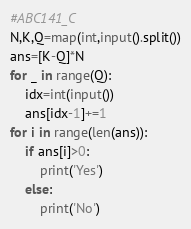<code> <loc_0><loc_0><loc_500><loc_500><_Python_>#ABC141_C
N,K,Q=map(int,input().split())
ans=[K-Q]*N
for _ in range(Q):
    idx=int(input())
    ans[idx-1]+=1
for i in range(len(ans)):
    if ans[i]>0:
        print('Yes')
    else:
        print('No')  </code> 